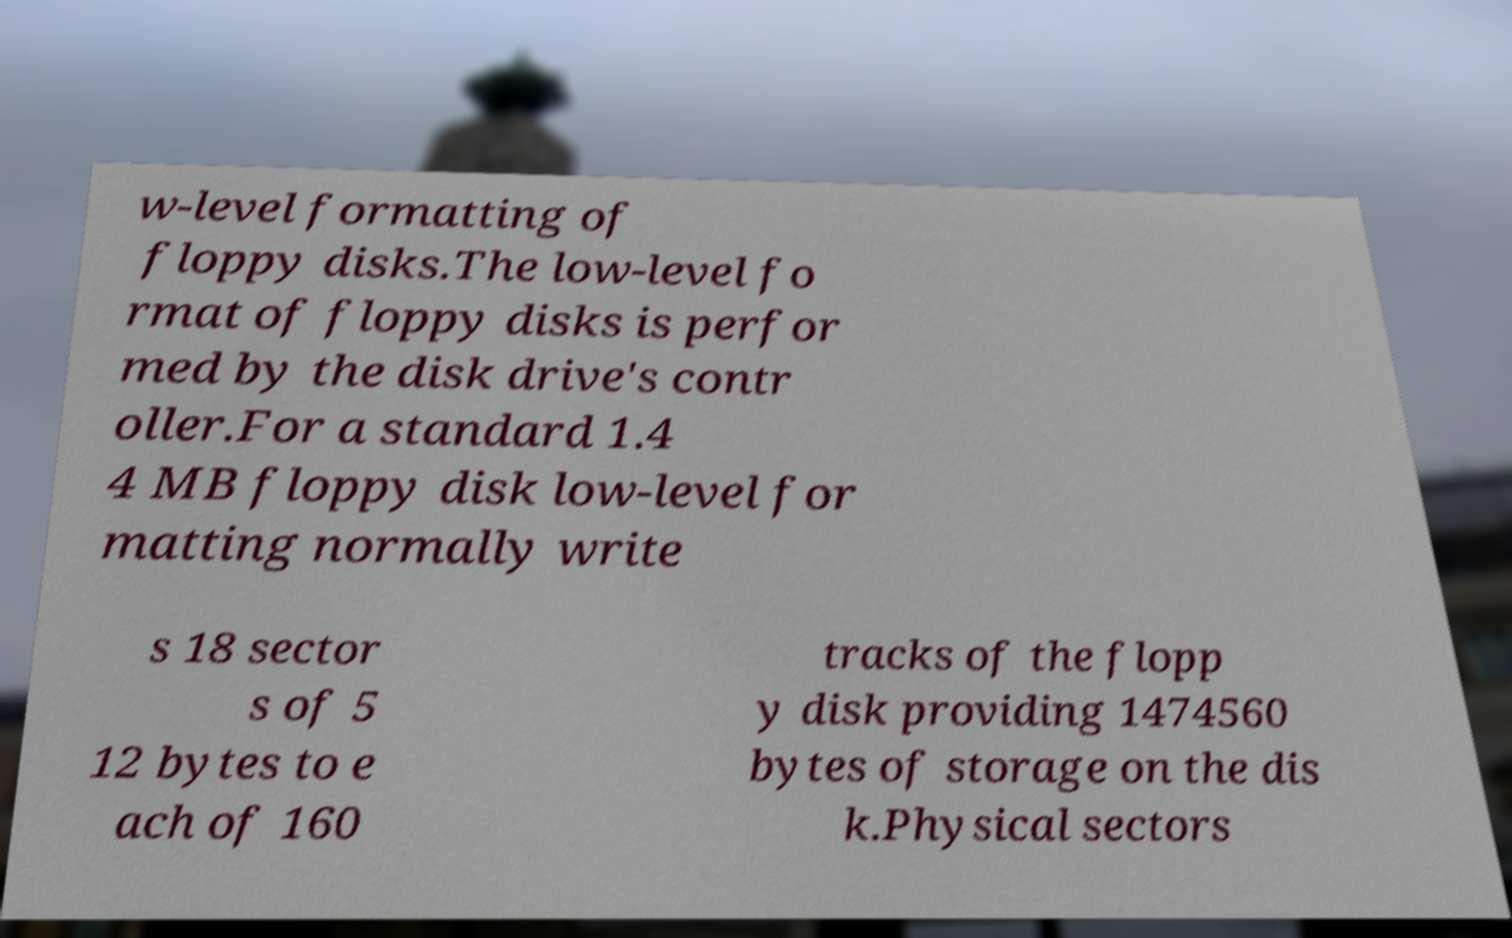What messages or text are displayed in this image? I need them in a readable, typed format. w-level formatting of floppy disks.The low-level fo rmat of floppy disks is perfor med by the disk drive's contr oller.For a standard 1.4 4 MB floppy disk low-level for matting normally write s 18 sector s of 5 12 bytes to e ach of 160 tracks of the flopp y disk providing 1474560 bytes of storage on the dis k.Physical sectors 